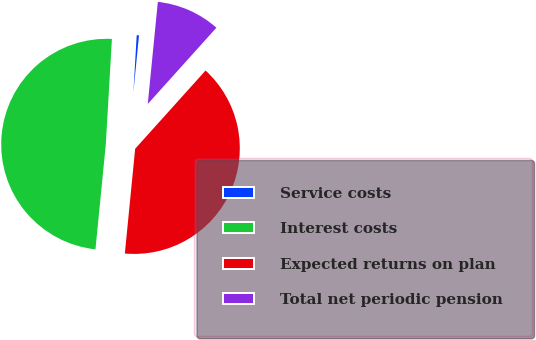<chart> <loc_0><loc_0><loc_500><loc_500><pie_chart><fcel>Service costs<fcel>Interest costs<fcel>Expected returns on plan<fcel>Total net periodic pension<nl><fcel>0.64%<fcel>49.36%<fcel>39.9%<fcel>10.1%<nl></chart> 